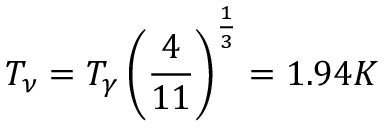<formula> <loc_0><loc_0><loc_500><loc_500>T _ { \nu } = T _ { \gamma } \left ( { \frac { 4 } { 1 1 } } \right ) ^ { \frac { 1 } { 3 } } = 1 . 9 4 K</formula> 